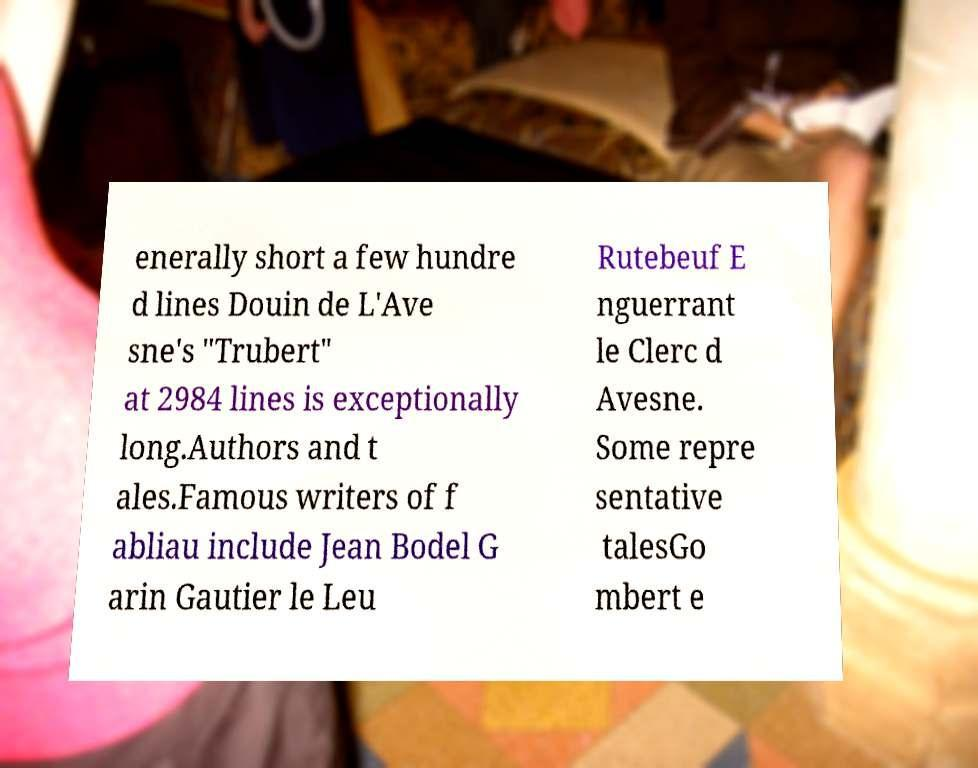Please identify and transcribe the text found in this image. enerally short a few hundre d lines Douin de L'Ave sne's "Trubert" at 2984 lines is exceptionally long.Authors and t ales.Famous writers of f abliau include Jean Bodel G arin Gautier le Leu Rutebeuf E nguerrant le Clerc d Avesne. Some repre sentative talesGo mbert e 